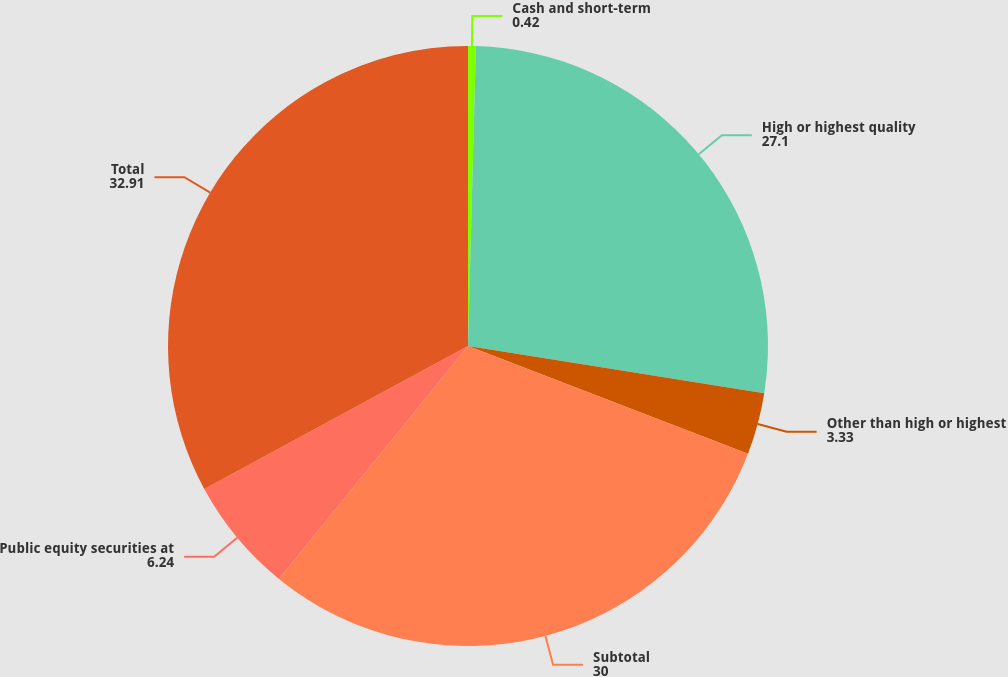<chart> <loc_0><loc_0><loc_500><loc_500><pie_chart><fcel>Cash and short-term<fcel>High or highest quality<fcel>Other than high or highest<fcel>Subtotal<fcel>Public equity securities at<fcel>Total<nl><fcel>0.42%<fcel>27.1%<fcel>3.33%<fcel>30.0%<fcel>6.24%<fcel>32.91%<nl></chart> 